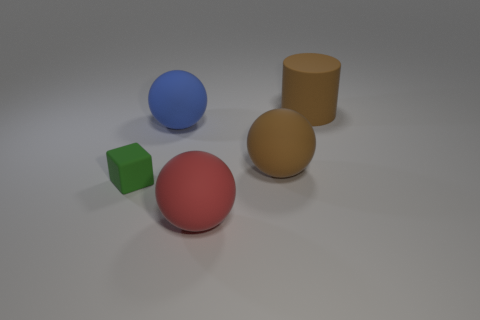Subtract all red matte balls. How many balls are left? 2 Add 3 large brown cylinders. How many objects exist? 8 Subtract all spheres. How many objects are left? 2 Subtract all big things. Subtract all green rubber things. How many objects are left? 0 Add 4 matte balls. How many matte balls are left? 7 Add 2 purple shiny blocks. How many purple shiny blocks exist? 2 Subtract 0 cyan cylinders. How many objects are left? 5 